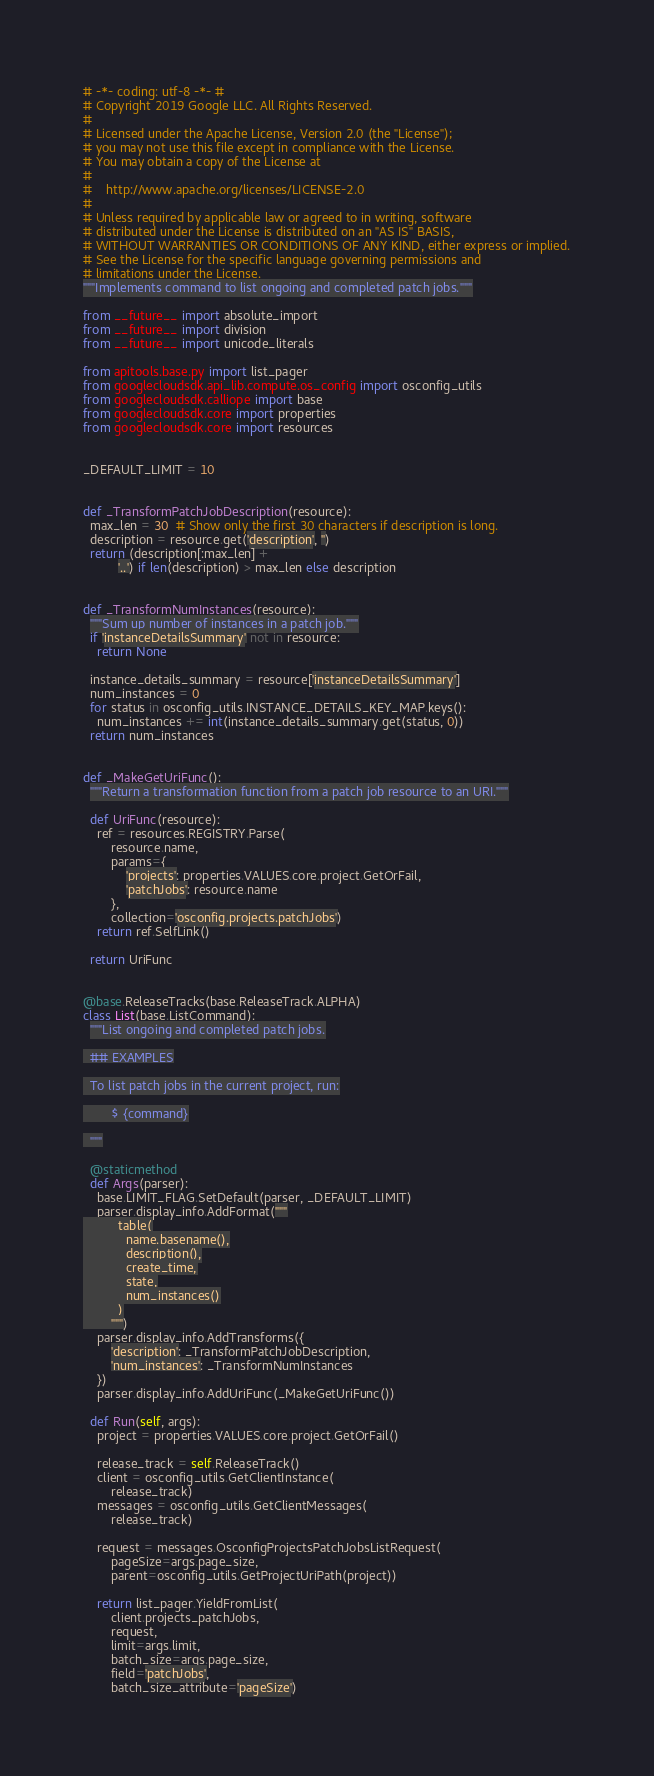<code> <loc_0><loc_0><loc_500><loc_500><_Python_># -*- coding: utf-8 -*- #
# Copyright 2019 Google LLC. All Rights Reserved.
#
# Licensed under the Apache License, Version 2.0 (the "License");
# you may not use this file except in compliance with the License.
# You may obtain a copy of the License at
#
#    http://www.apache.org/licenses/LICENSE-2.0
#
# Unless required by applicable law or agreed to in writing, software
# distributed under the License is distributed on an "AS IS" BASIS,
# WITHOUT WARRANTIES OR CONDITIONS OF ANY KIND, either express or implied.
# See the License for the specific language governing permissions and
# limitations under the License.
"""Implements command to list ongoing and completed patch jobs."""

from __future__ import absolute_import
from __future__ import division
from __future__ import unicode_literals

from apitools.base.py import list_pager
from googlecloudsdk.api_lib.compute.os_config import osconfig_utils
from googlecloudsdk.calliope import base
from googlecloudsdk.core import properties
from googlecloudsdk.core import resources


_DEFAULT_LIMIT = 10


def _TransformPatchJobDescription(resource):
  max_len = 30  # Show only the first 30 characters if description is long.
  description = resource.get('description', '')
  return (description[:max_len] +
          '..') if len(description) > max_len else description


def _TransformNumInstances(resource):
  """Sum up number of instances in a patch job."""
  if 'instanceDetailsSummary' not in resource:
    return None

  instance_details_summary = resource['instanceDetailsSummary']
  num_instances = 0
  for status in osconfig_utils.INSTANCE_DETAILS_KEY_MAP.keys():
    num_instances += int(instance_details_summary.get(status, 0))
  return num_instances


def _MakeGetUriFunc():
  """Return a transformation function from a patch job resource to an URI."""

  def UriFunc(resource):
    ref = resources.REGISTRY.Parse(
        resource.name,
        params={
            'projects': properties.VALUES.core.project.GetOrFail,
            'patchJobs': resource.name
        },
        collection='osconfig.projects.patchJobs')
    return ref.SelfLink()

  return UriFunc


@base.ReleaseTracks(base.ReleaseTrack.ALPHA)
class List(base.ListCommand):
  """List ongoing and completed patch jobs.

  ## EXAMPLES

  To list patch jobs in the current project, run:

        $ {command}

  """

  @staticmethod
  def Args(parser):
    base.LIMIT_FLAG.SetDefault(parser, _DEFAULT_LIMIT)
    parser.display_info.AddFormat("""
          table(
            name.basename(),
            description(),
            create_time,
            state,
            num_instances()
          )
        """)
    parser.display_info.AddTransforms({
        'description': _TransformPatchJobDescription,
        'num_instances': _TransformNumInstances
    })
    parser.display_info.AddUriFunc(_MakeGetUriFunc())

  def Run(self, args):
    project = properties.VALUES.core.project.GetOrFail()

    release_track = self.ReleaseTrack()
    client = osconfig_utils.GetClientInstance(
        release_track)
    messages = osconfig_utils.GetClientMessages(
        release_track)

    request = messages.OsconfigProjectsPatchJobsListRequest(
        pageSize=args.page_size,
        parent=osconfig_utils.GetProjectUriPath(project))

    return list_pager.YieldFromList(
        client.projects_patchJobs,
        request,
        limit=args.limit,
        batch_size=args.page_size,
        field='patchJobs',
        batch_size_attribute='pageSize')
</code> 